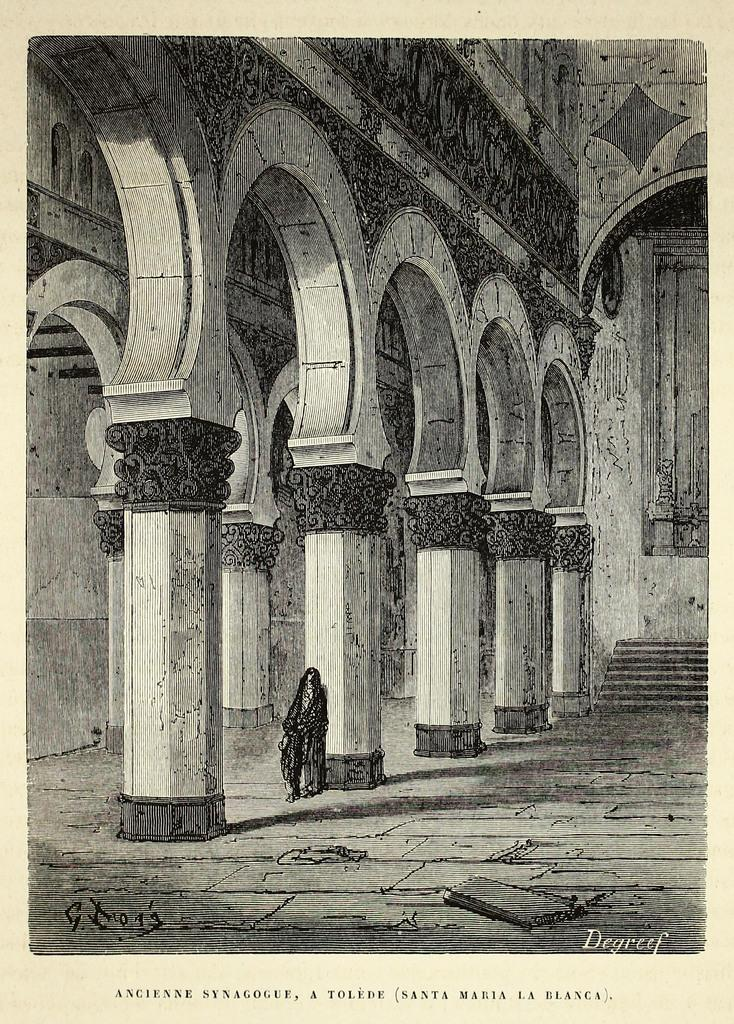What architectural features can be seen in the image? There are pillars in the image. Can you describe the person's position in relation to the pillar? A person is standing beside a pillar. What is located on the right side of the image? There are stairs and a wall on the right side of the image. What type of activity are the boats involved in within the image? There are no boats present in the image. 